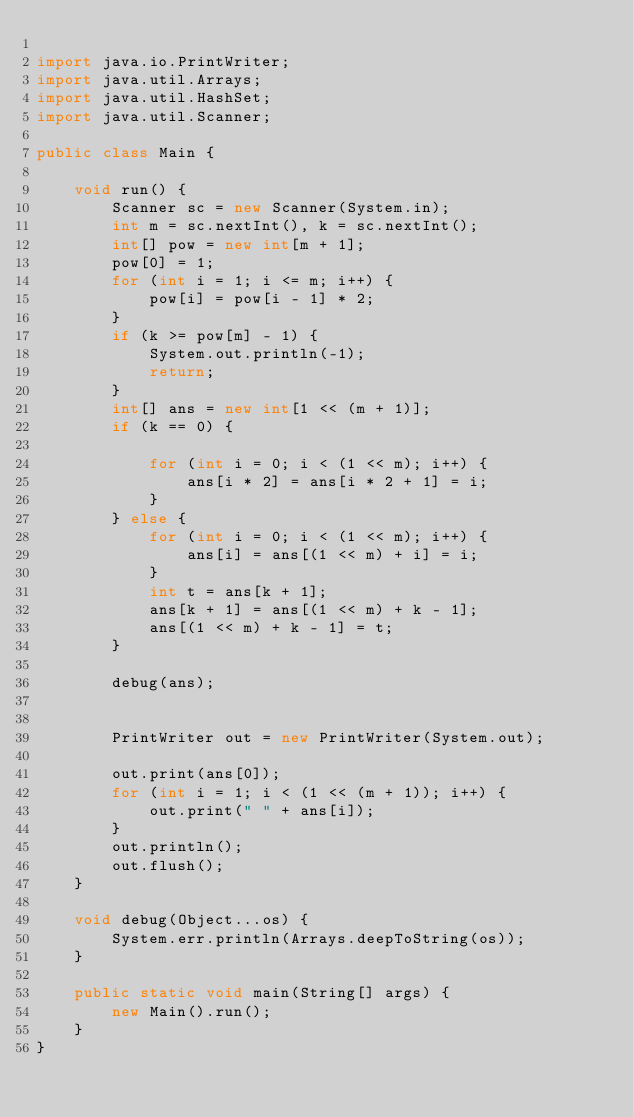Convert code to text. <code><loc_0><loc_0><loc_500><loc_500><_Java_>
import java.io.PrintWriter;
import java.util.Arrays;
import java.util.HashSet;
import java.util.Scanner;

public class Main {

    void run() {
        Scanner sc = new Scanner(System.in);
        int m = sc.nextInt(), k = sc.nextInt();
        int[] pow = new int[m + 1];
        pow[0] = 1;
        for (int i = 1; i <= m; i++) {
            pow[i] = pow[i - 1] * 2;
        }
        if (k >= pow[m] - 1) {
            System.out.println(-1);
            return;
        }
        int[] ans = new int[1 << (m + 1)];
        if (k == 0) {

            for (int i = 0; i < (1 << m); i++) {
                ans[i * 2] = ans[i * 2 + 1] = i;
            }
        } else {
            for (int i = 0; i < (1 << m); i++) {
                ans[i] = ans[(1 << m) + i] = i;
            }
            int t = ans[k + 1];
            ans[k + 1] = ans[(1 << m) + k - 1];
            ans[(1 << m) + k - 1] = t;
        }

        debug(ans);


        PrintWriter out = new PrintWriter(System.out);

        out.print(ans[0]);
        for (int i = 1; i < (1 << (m + 1)); i++) {
            out.print(" " + ans[i]);
        }
        out.println();
        out.flush();
    }

    void debug(Object...os) {
        System.err.println(Arrays.deepToString(os));
    }

    public static void main(String[] args) {
        new Main().run();
    }
}
</code> 